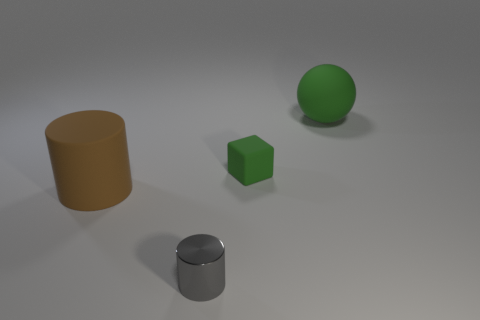The metallic thing is what color?
Your answer should be compact. Gray. There is a large thing that is on the left side of the block; are there any brown matte things behind it?
Your response must be concise. No. What number of brown matte things are the same size as the brown rubber cylinder?
Keep it short and to the point. 0. There is a green rubber object in front of the large green matte ball right of the metallic cylinder; what number of green objects are behind it?
Ensure brevity in your answer.  1. What number of matte things are both right of the large cylinder and in front of the large ball?
Provide a short and direct response. 1. Is there any other thing that has the same color as the tiny metallic object?
Your answer should be very brief. No. What number of matte objects are small yellow objects or large brown objects?
Offer a terse response. 1. What is the material of the large thing that is to the left of the tiny matte thing that is right of the rubber object that is in front of the small green rubber cube?
Provide a succinct answer. Rubber. There is a large object to the left of the thing that is in front of the brown object; what is its material?
Provide a short and direct response. Rubber. There is a green thing that is behind the tiny matte thing; does it have the same size as the matte thing on the left side of the block?
Your response must be concise. Yes. 